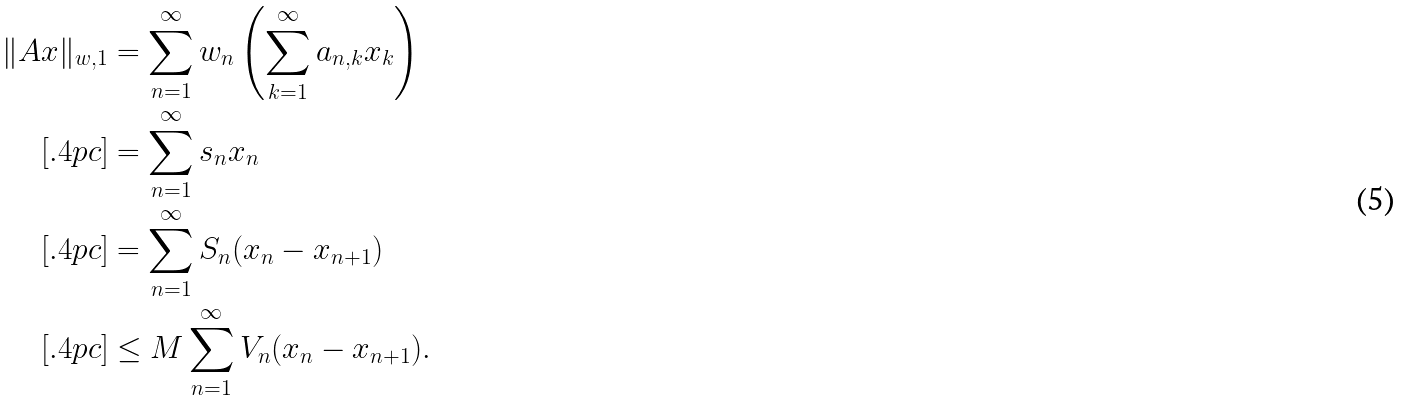Convert formula to latex. <formula><loc_0><loc_0><loc_500><loc_500>\| A x \| _ { w , 1 } & = \sum _ { n = 1 } ^ { \infty } w _ { n } \left ( \sum _ { k = 1 } ^ { \infty } a _ { n , k } x _ { k } \right ) \\ [ . 4 p c ] & = \sum _ { n = 1 } ^ { \infty } s _ { n } x _ { n } \\ [ . 4 p c ] & = \sum _ { n = 1 } ^ { \infty } S _ { n } ( x _ { n } - x _ { n + 1 } ) \\ [ . 4 p c ] & \leq M \sum _ { n = 1 } ^ { \infty } V _ { n } ( x _ { n } - x _ { n + 1 } ) .</formula> 